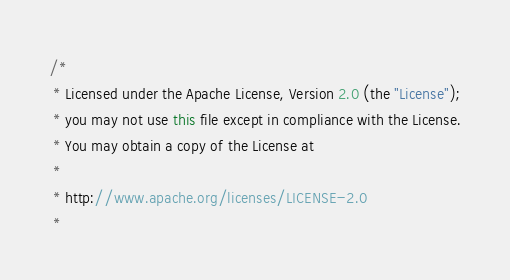Convert code to text. <code><loc_0><loc_0><loc_500><loc_500><_Java_>/*
 * Licensed under the Apache License, Version 2.0 (the "License");
 * you may not use this file except in compliance with the License.
 * You may obtain a copy of the License at
 *
 * http://www.apache.org/licenses/LICENSE-2.0
 *</code> 